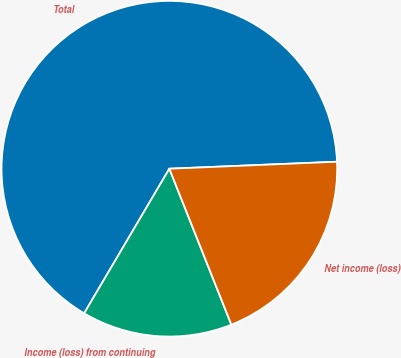<chart> <loc_0><loc_0><loc_500><loc_500><pie_chart><fcel>Total<fcel>Income (loss) from continuing<fcel>Net income (loss)<nl><fcel>65.86%<fcel>14.5%<fcel>19.64%<nl></chart> 